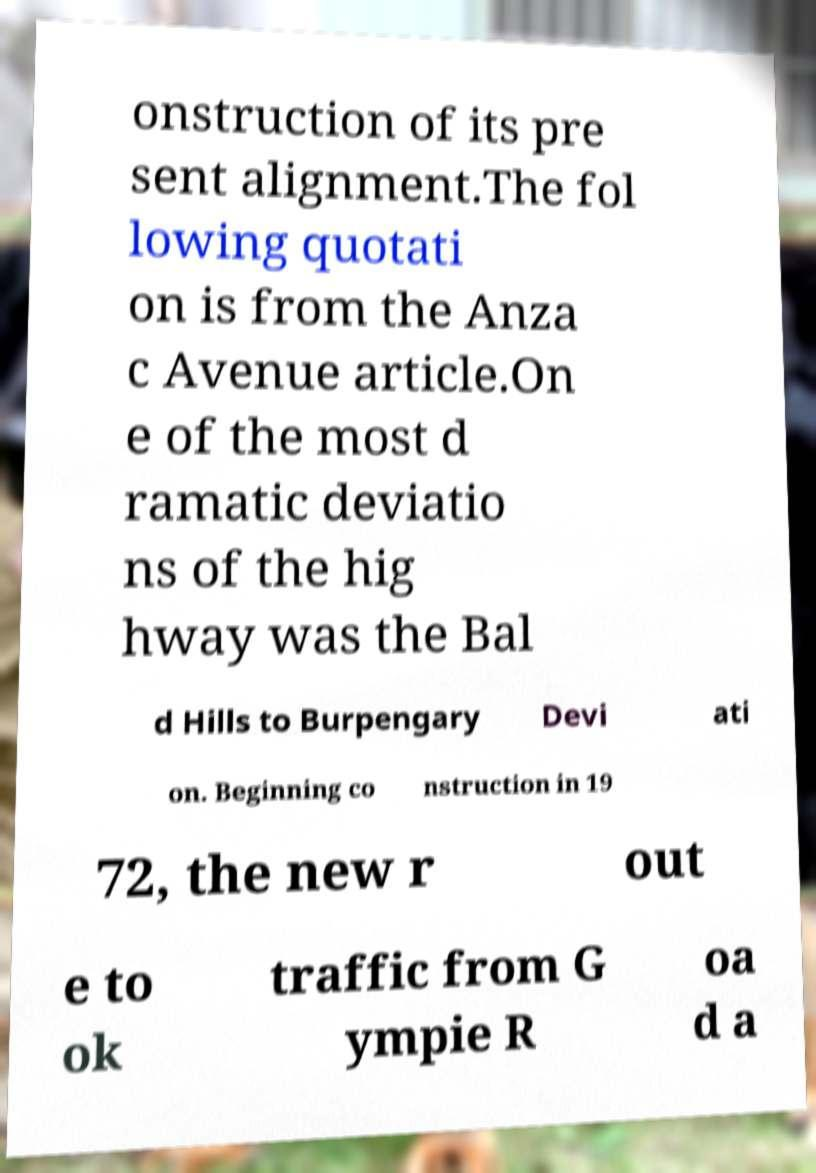What messages or text are displayed in this image? I need them in a readable, typed format. onstruction of its pre sent alignment.The fol lowing quotati on is from the Anza c Avenue article.On e of the most d ramatic deviatio ns of the hig hway was the Bal d Hills to Burpengary Devi ati on. Beginning co nstruction in 19 72, the new r out e to ok traffic from G ympie R oa d a 